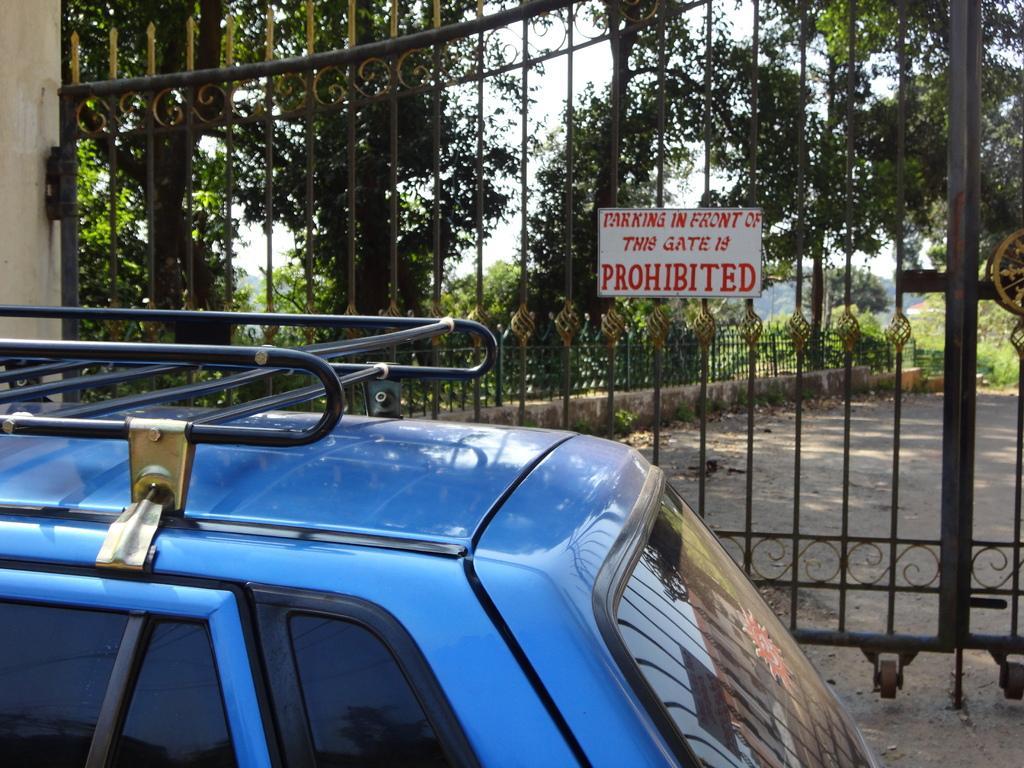Can you describe this image briefly? In this image there is the sky towards the top of the image, there are trees, there is a fence, there is a gate, there is a board, there is text on the board, there is ground towards the right of the image, there is a vehicle towards the bottom of the image, there is a wall towards the left of the image. 